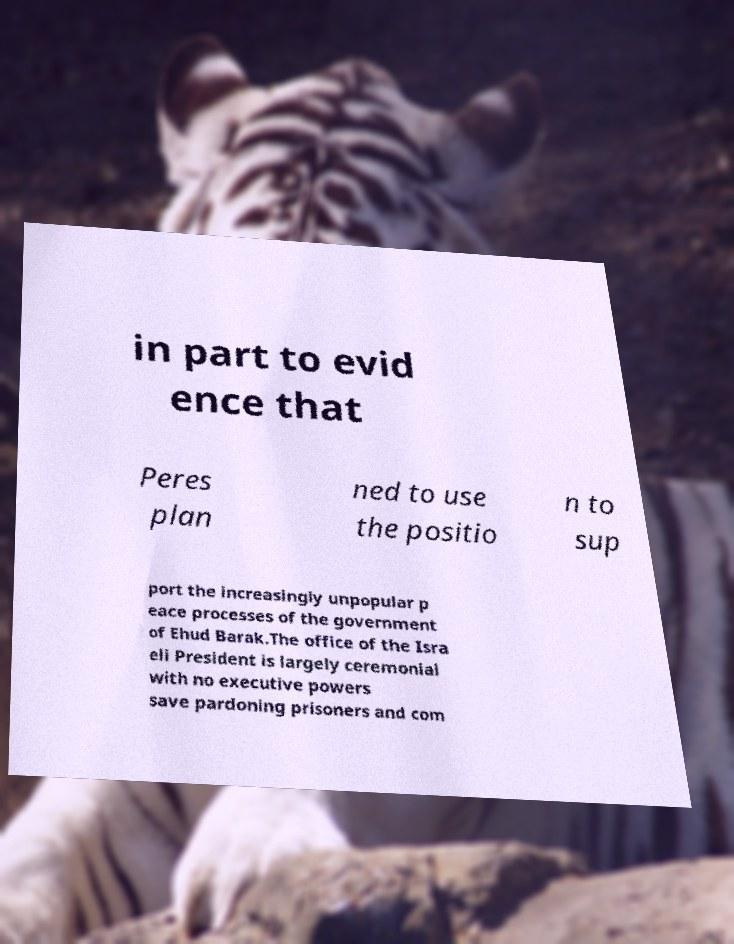Could you extract and type out the text from this image? in part to evid ence that Peres plan ned to use the positio n to sup port the increasingly unpopular p eace processes of the government of Ehud Barak.The office of the Isra eli President is largely ceremonial with no executive powers save pardoning prisoners and com 